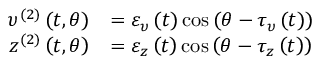Convert formula to latex. <formula><loc_0><loc_0><loc_500><loc_500>\begin{array} { r l } { \upsilon ^ { ( 2 ) } \left ( t , \theta \right ) } & { = \varepsilon _ { \upsilon } \left ( t \right ) \cos \left ( \theta - \tau _ { \upsilon } \left ( t \right ) \right ) } \\ { z ^ { ( 2 ) } \left ( t , \theta \right ) } & { = \varepsilon _ { z } \left ( t \right ) \cos \left ( \theta - \tau _ { z } \left ( t \right ) \right ) } \end{array}</formula> 